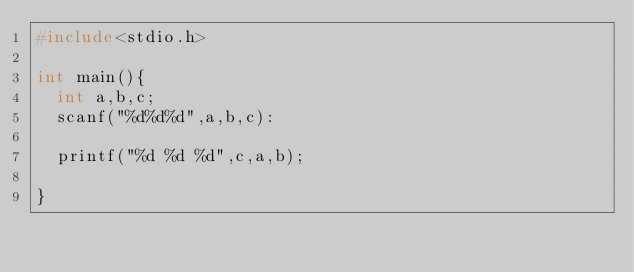<code> <loc_0><loc_0><loc_500><loc_500><_C_>#include<stdio.h>

int main(){
  int a,b,c;
  scanf("%d%d%d",a,b,c):
  
  printf("%d %d %d",c,a,b);
  
}</code> 